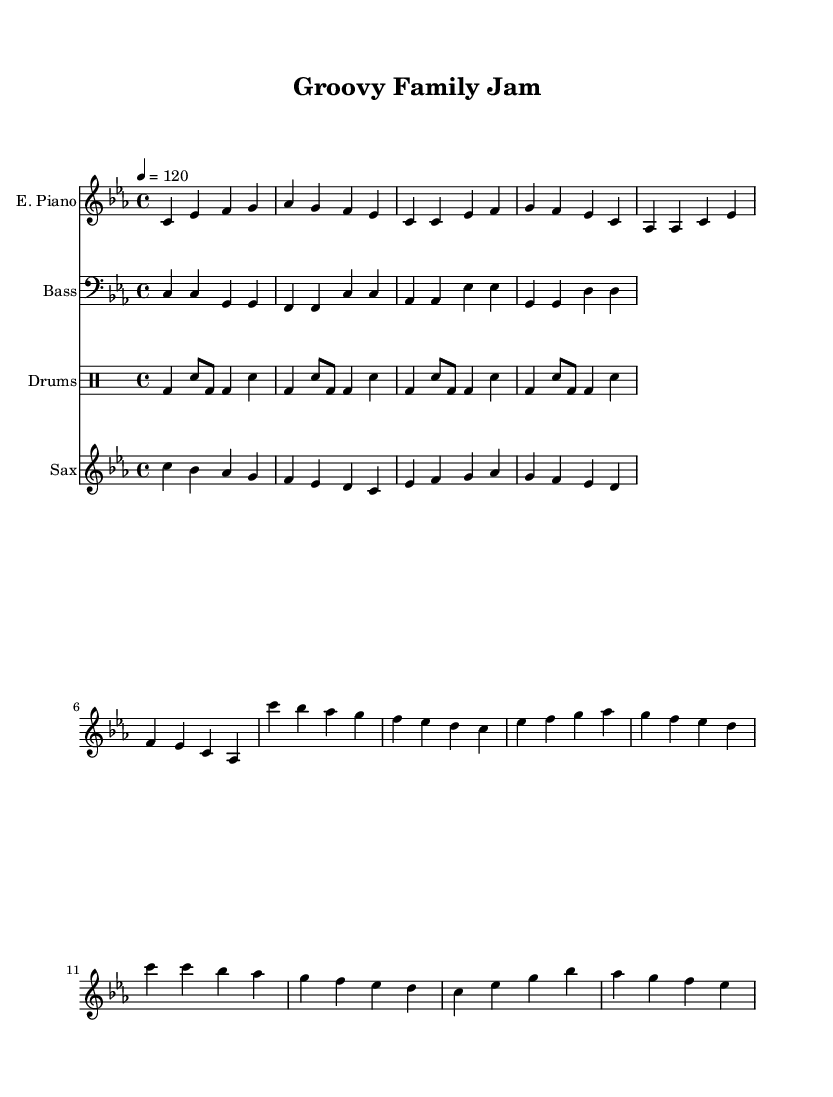What is the key signature of this music? The key signature is C minor, which has three flats (B♭, E♭, and A♭). This is indicated at the beginning of the music score.
Answer: C minor What is the time signature of the music? The time signature shown at the beginning of the score is 4/4, indicating four beats per measure and a quarter note receives one beat.
Answer: 4/4 What is the tempo marking of this piece? The tempo marking indicates the speed of the music; in this case, it shows a tempo of quarter note equals 120 beats per minute, specifying how fast the piece should be played.
Answer: 120 How many measures are in the Dance Break section? By visually counting the measures in the Dance Break section of the score, you find that there are four measures, as indicated by the grouping of notes.
Answer: 4 What instrument plays the main jazz lines? In the context of this score, the electric piano part primarily carries the main jazz lines, providing both harmonic and melodic elements throughout the piece.
Answer: Electric Piano What rhythm pattern is predominantly used in the drums? The drums mainly feature a basic funk groove, characterized by a consistent kick drum on the downbeats and snare on the backbeats, creating an infectious rhythmic feel.
Answer: Basic funk groove What family activity is this music intended for? The title and overall vibe of the piece suggest it is meant for family bonding and dance breaks, making it suitable for leisurely activities like family jams at home.
Answer: Family bonding 